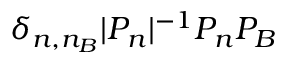Convert formula to latex. <formula><loc_0><loc_0><loc_500><loc_500>\delta _ { n , n _ { B } } | P _ { n } | ^ { - 1 } P _ { n } P _ { B }</formula> 